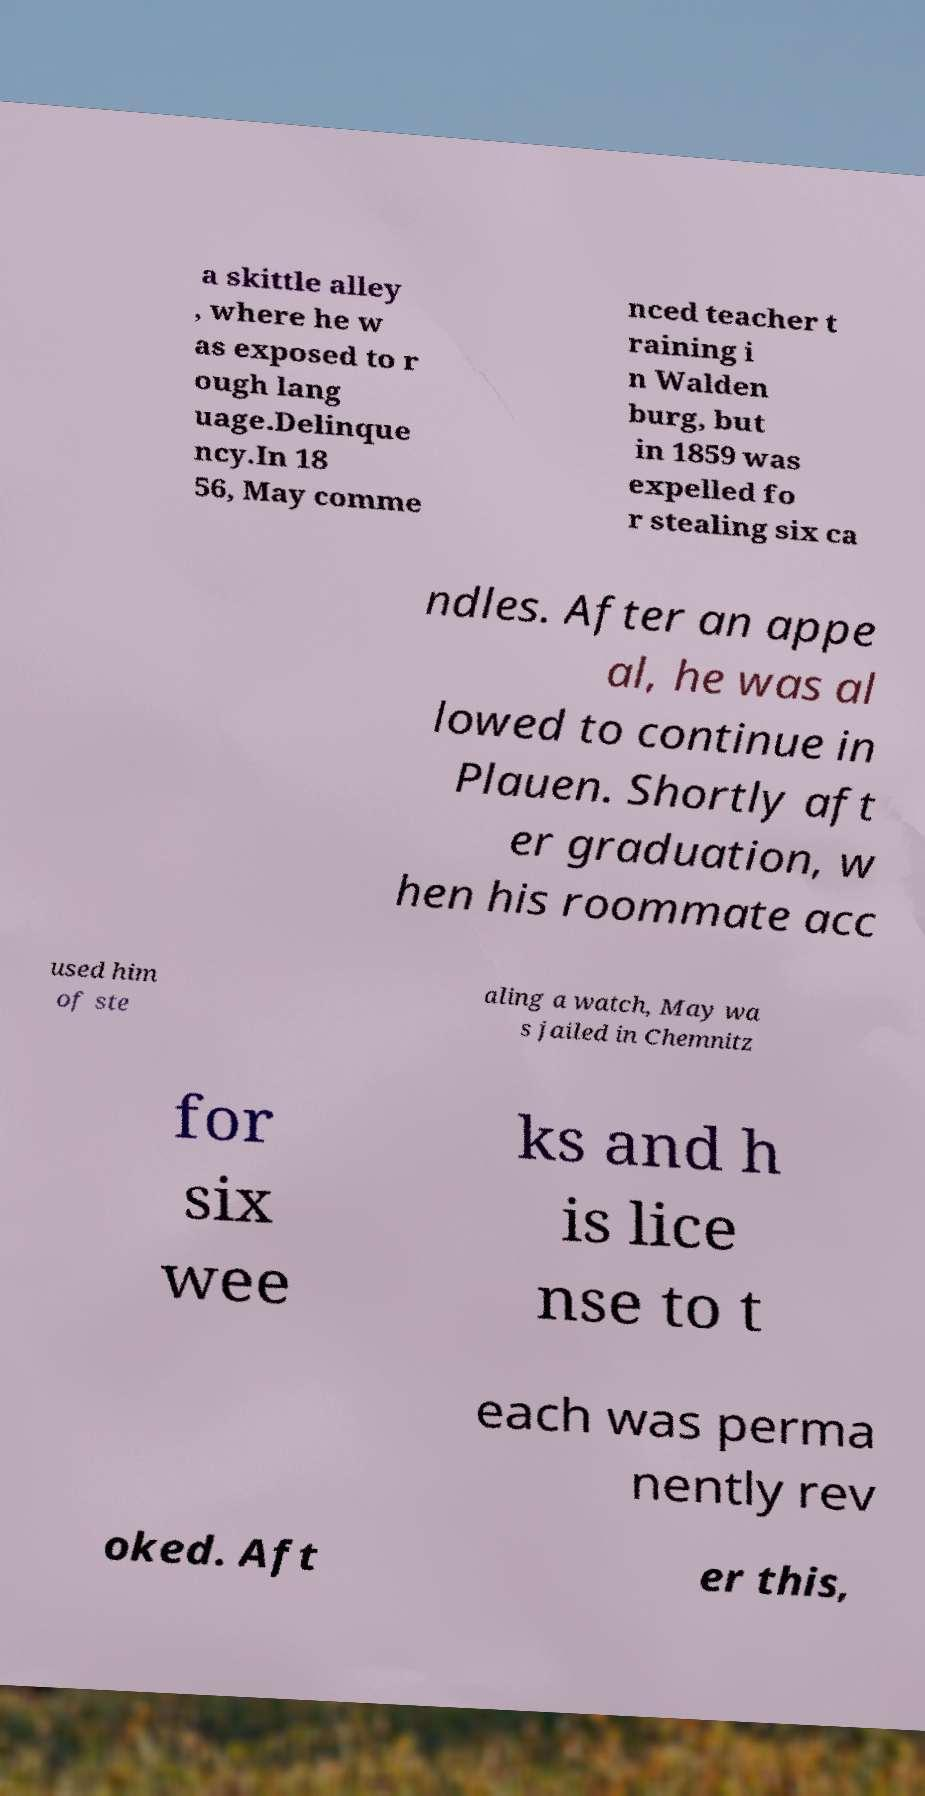There's text embedded in this image that I need extracted. Can you transcribe it verbatim? a skittle alley , where he w as exposed to r ough lang uage.Delinque ncy.In 18 56, May comme nced teacher t raining i n Walden burg, but in 1859 was expelled fo r stealing six ca ndles. After an appe al, he was al lowed to continue in Plauen. Shortly aft er graduation, w hen his roommate acc used him of ste aling a watch, May wa s jailed in Chemnitz for six wee ks and h is lice nse to t each was perma nently rev oked. Aft er this, 